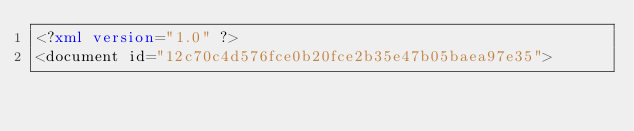<code> <loc_0><loc_0><loc_500><loc_500><_XML_><?xml version="1.0" ?>
<document id="12c70c4d576fce0b20fce2b35e47b05baea97e35"></code> 